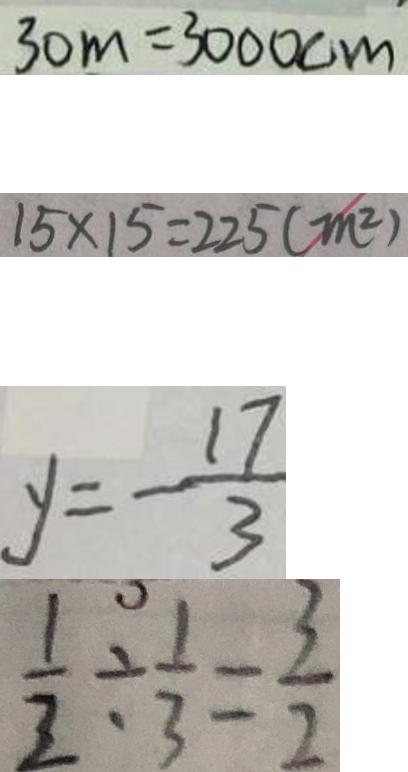Convert formula to latex. <formula><loc_0><loc_0><loc_500><loc_500>3 0 m = 3 0 0 0 c m 
 1 5 \times 1 5 = 2 2 5 ( m ^ { 2 } ) 
 y = - \frac { 1 7 } { 3 } 
 \frac { 1 } { 2 } \div \frac { 1 } { 3 } = \frac { 3 } { 2 }</formula> 